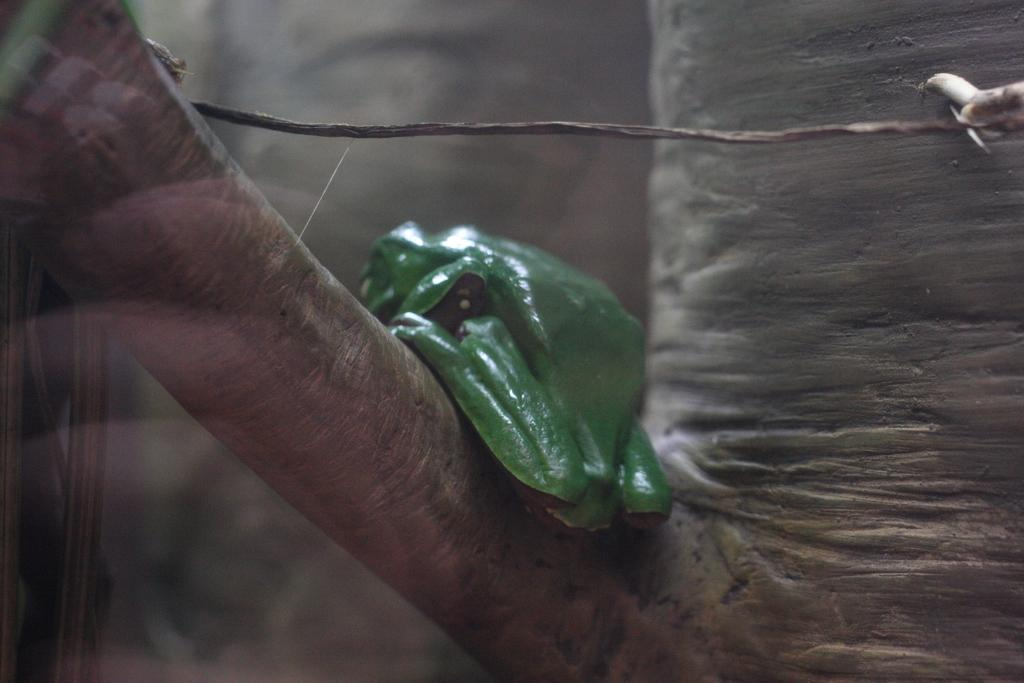What animal is present in the image? There is a frog in the image. Where is the frog located? The frog is on a tree. Can you describe the position of the tree in the image? The tree is in the center of the image. What type of bead is hanging from the window in the image? There is no window or bead present in the image; it features a frog on a tree. 